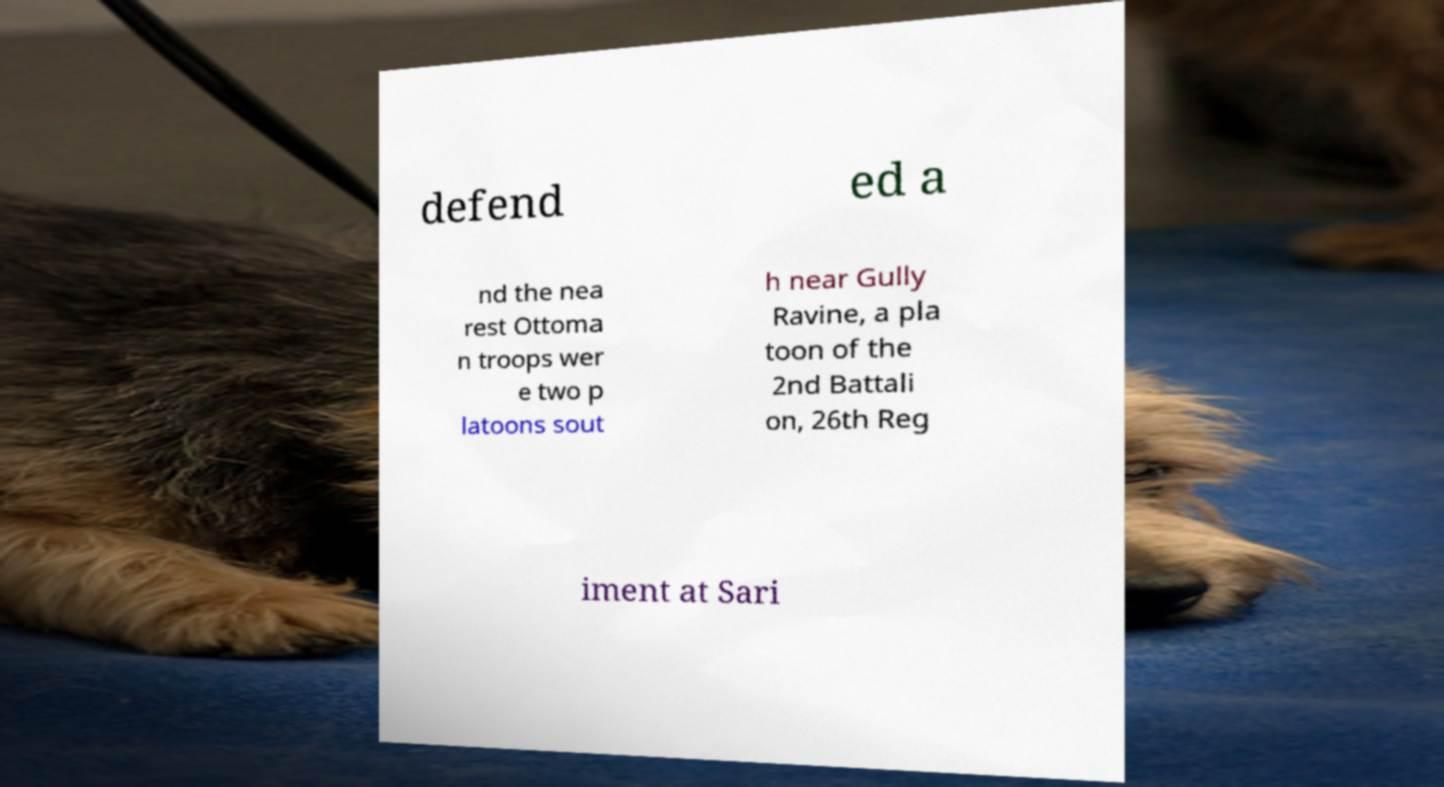Please read and relay the text visible in this image. What does it say? defend ed a nd the nea rest Ottoma n troops wer e two p latoons sout h near Gully Ravine, a pla toon of the 2nd Battali on, 26th Reg iment at Sari 